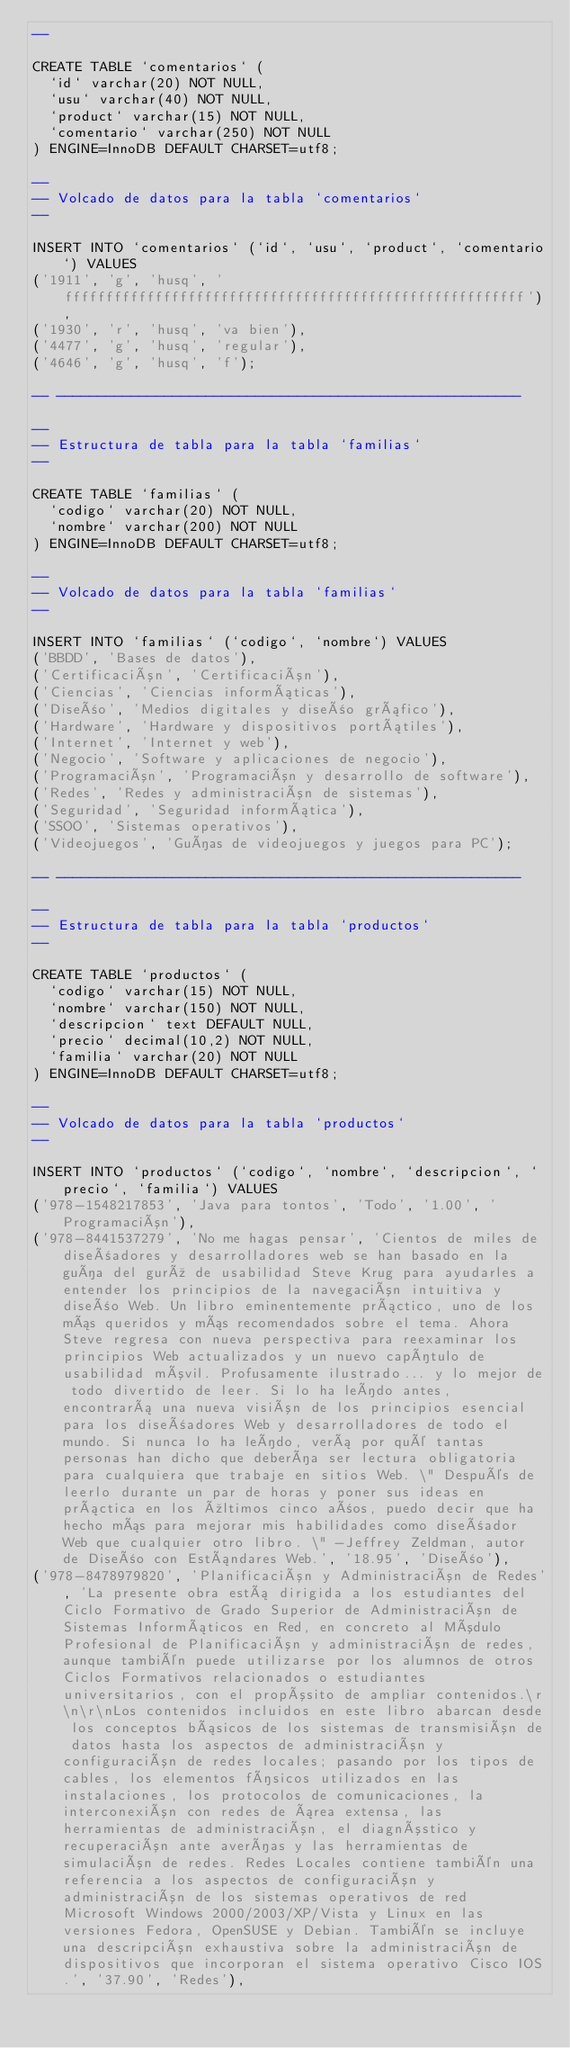Convert code to text. <code><loc_0><loc_0><loc_500><loc_500><_SQL_>--

CREATE TABLE `comentarios` (
  `id` varchar(20) NOT NULL,
  `usu` varchar(40) NOT NULL,
  `product` varchar(15) NOT NULL,
  `comentario` varchar(250) NOT NULL
) ENGINE=InnoDB DEFAULT CHARSET=utf8;

--
-- Volcado de datos para la tabla `comentarios`
--

INSERT INTO `comentarios` (`id`, `usu`, `product`, `comentario`) VALUES
('1911', 'g', 'husq', 'ffffffffffffffffffffffffffffffffffffffffffffffffffffffff'),
('1930', 'r', 'husq', 'va bien'),
('4477', 'g', 'husq', 'regular'),
('4646', 'g', 'husq', 'f');

-- --------------------------------------------------------

--
-- Estructura de tabla para la tabla `familias`
--

CREATE TABLE `familias` (
  `codigo` varchar(20) NOT NULL,
  `nombre` varchar(200) NOT NULL
) ENGINE=InnoDB DEFAULT CHARSET=utf8;

--
-- Volcado de datos para la tabla `familias`
--

INSERT INTO `familias` (`codigo`, `nombre`) VALUES
('BBDD', 'Bases de datos'),
('Certificación', 'Certificación'),
('Ciencias', 'Ciencias informáticas'),
('Diseño', 'Medios digitales y diseño gráfico'),
('Hardware', 'Hardware y dispositivos portátiles'),
('Internet', 'Internet y web'),
('Negocio', 'Software y aplicaciones de negocio'),
('Programación', 'Programación y desarrollo de software'),
('Redes', 'Redes y administración de sistemas'),
('Seguridad', 'Seguridad informática'),
('SSOO', 'Sistemas operativos'),
('Videojuegos', 'Guías de videojuegos y juegos para PC');

-- --------------------------------------------------------

--
-- Estructura de tabla para la tabla `productos`
--

CREATE TABLE `productos` (
  `codigo` varchar(15) NOT NULL,
  `nombre` varchar(150) NOT NULL,
  `descripcion` text DEFAULT NULL,
  `precio` decimal(10,2) NOT NULL,
  `familia` varchar(20) NOT NULL
) ENGINE=InnoDB DEFAULT CHARSET=utf8;

--
-- Volcado de datos para la tabla `productos`
--

INSERT INTO `productos` (`codigo`, `nombre`, `descripcion`, `precio`, `familia`) VALUES
('978-1548217853', 'Java para tontos', 'Todo', '1.00', 'Programación'),
('978-8441537279', 'No me hagas pensar', 'Cientos de miles de diseñadores y desarrolladores web se han basado en la guía del gurú de usabilidad Steve Krug para ayudarles a entender los principios de la navegación intuitiva y diseño Web. Un libro eminentemente práctico, uno de los más queridos y más recomendados sobre el tema. Ahora Steve regresa con nueva perspectiva para reexaminar los principios Web actualizados y un nuevo capítulo de usabilidad móvil. Profusamente ilustrado... y lo mejor de todo divertido de leer. Si lo ha leído antes, encontrará una nueva visión de los principios esencial para los diseñadores Web y desarrolladores de todo el mundo. Si nunca lo ha leído, verá por qué tantas personas han dicho que debería ser lectura obligatoria para cualquiera que trabaje en sitios Web. \" Después de leerlo durante un par de horas y poner sus ideas en práctica en los últimos cinco años, puedo decir que ha hecho más para mejorar mis habilidades como diseñador Web que cualquier otro libro. \" -Jeffrey Zeldman, autor de Diseño con Estándares Web.', '18.95', 'Diseño'),
('978-8478979820', 'Planificación y Administración de Redes', 'La presente obra está dirigida a los estudiantes del Ciclo Formativo de Grado Superior de Administración de Sistemas Informáticos en Red, en concreto al Módulo Profesional de Planificación y administración de redes, aunque también puede utilizarse por los alumnos de otros Ciclos Formativos relacionados o estudiantes universitarios, con el propósito de ampliar contenidos.\r\n\r\nLos contenidos incluidos en este libro abarcan desde los conceptos básicos de los sistemas de transmisión de datos hasta los aspectos de administración y configuración de redes locales; pasando por los tipos de cables, los elementos físicos utilizados en las instalaciones, los protocolos de comunicaciones, la interconexión con redes de área extensa, las herramientas de administración, el diagnóstico y recuperación ante averías y las herramientas de simulación de redes. Redes Locales contiene también una referencia a los aspectos de configuración y administración de los sistemas operativos de red Microsoft Windows 2000/2003/XP/Vista y Linux en las versiones Fedora, OpenSUSE y Debian. También se incluye una descripción exhaustiva sobre la administración de dispositivos que incorporan el sistema operativo Cisco IOS.', '37.90', 'Redes'),</code> 